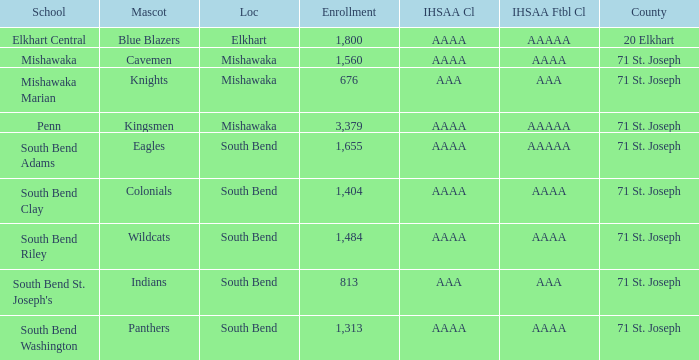Can you give me this table as a dict? {'header': ['School', 'Mascot', 'Loc', 'Enrollment', 'IHSAA Cl', 'IHSAA Ftbl Cl', 'County'], 'rows': [['Elkhart Central', 'Blue Blazers', 'Elkhart', '1,800', 'AAAA', 'AAAAA', '20 Elkhart'], ['Mishawaka', 'Cavemen', 'Mishawaka', '1,560', 'AAAA', 'AAAA', '71 St. Joseph'], ['Mishawaka Marian', 'Knights', 'Mishawaka', '676', 'AAA', 'AAA', '71 St. Joseph'], ['Penn', 'Kingsmen', 'Mishawaka', '3,379', 'AAAA', 'AAAAA', '71 St. Joseph'], ['South Bend Adams', 'Eagles', 'South Bend', '1,655', 'AAAA', 'AAAAA', '71 St. Joseph'], ['South Bend Clay', 'Colonials', 'South Bend', '1,404', 'AAAA', 'AAAA', '71 St. Joseph'], ['South Bend Riley', 'Wildcats', 'South Bend', '1,484', 'AAAA', 'AAAA', '71 St. Joseph'], ["South Bend St. Joseph's", 'Indians', 'South Bend', '813', 'AAA', 'AAA', '71 St. Joseph'], ['South Bend Washington', 'Panthers', 'South Bend', '1,313', 'AAAA', 'AAAA', '71 St. Joseph']]} What venue has kingsmen as the emblem? Mishawaka. 